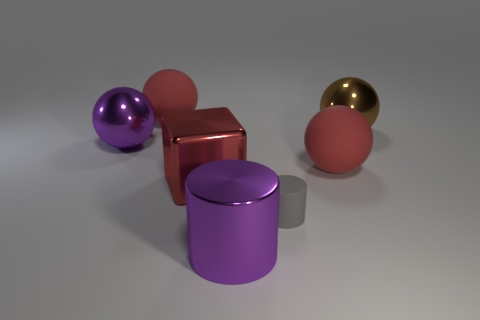How many balls are large red objects or big brown shiny objects?
Give a very brief answer. 3. There is a red matte object that is behind the big metallic sphere that is to the left of the big brown shiny object; what number of things are on the left side of it?
Offer a terse response. 1. There is a cylinder that is the same size as the brown sphere; what color is it?
Your answer should be compact. Purple. How many other things are the same color as the big metallic cube?
Your response must be concise. 2. Are there more metallic spheres that are in front of the purple shiny cylinder than brown objects?
Provide a short and direct response. No. Is the tiny gray cylinder made of the same material as the big brown sphere?
Offer a very short reply. No. What number of things are large matte spheres that are in front of the brown sphere or big gray shiny spheres?
Offer a very short reply. 1. What number of other things are there of the same size as the shiny cylinder?
Keep it short and to the point. 5. Is the number of gray matte cylinders in front of the tiny rubber object the same as the number of metal objects that are in front of the purple cylinder?
Keep it short and to the point. Yes. What is the color of the other metallic thing that is the same shape as the small thing?
Provide a short and direct response. Purple. 